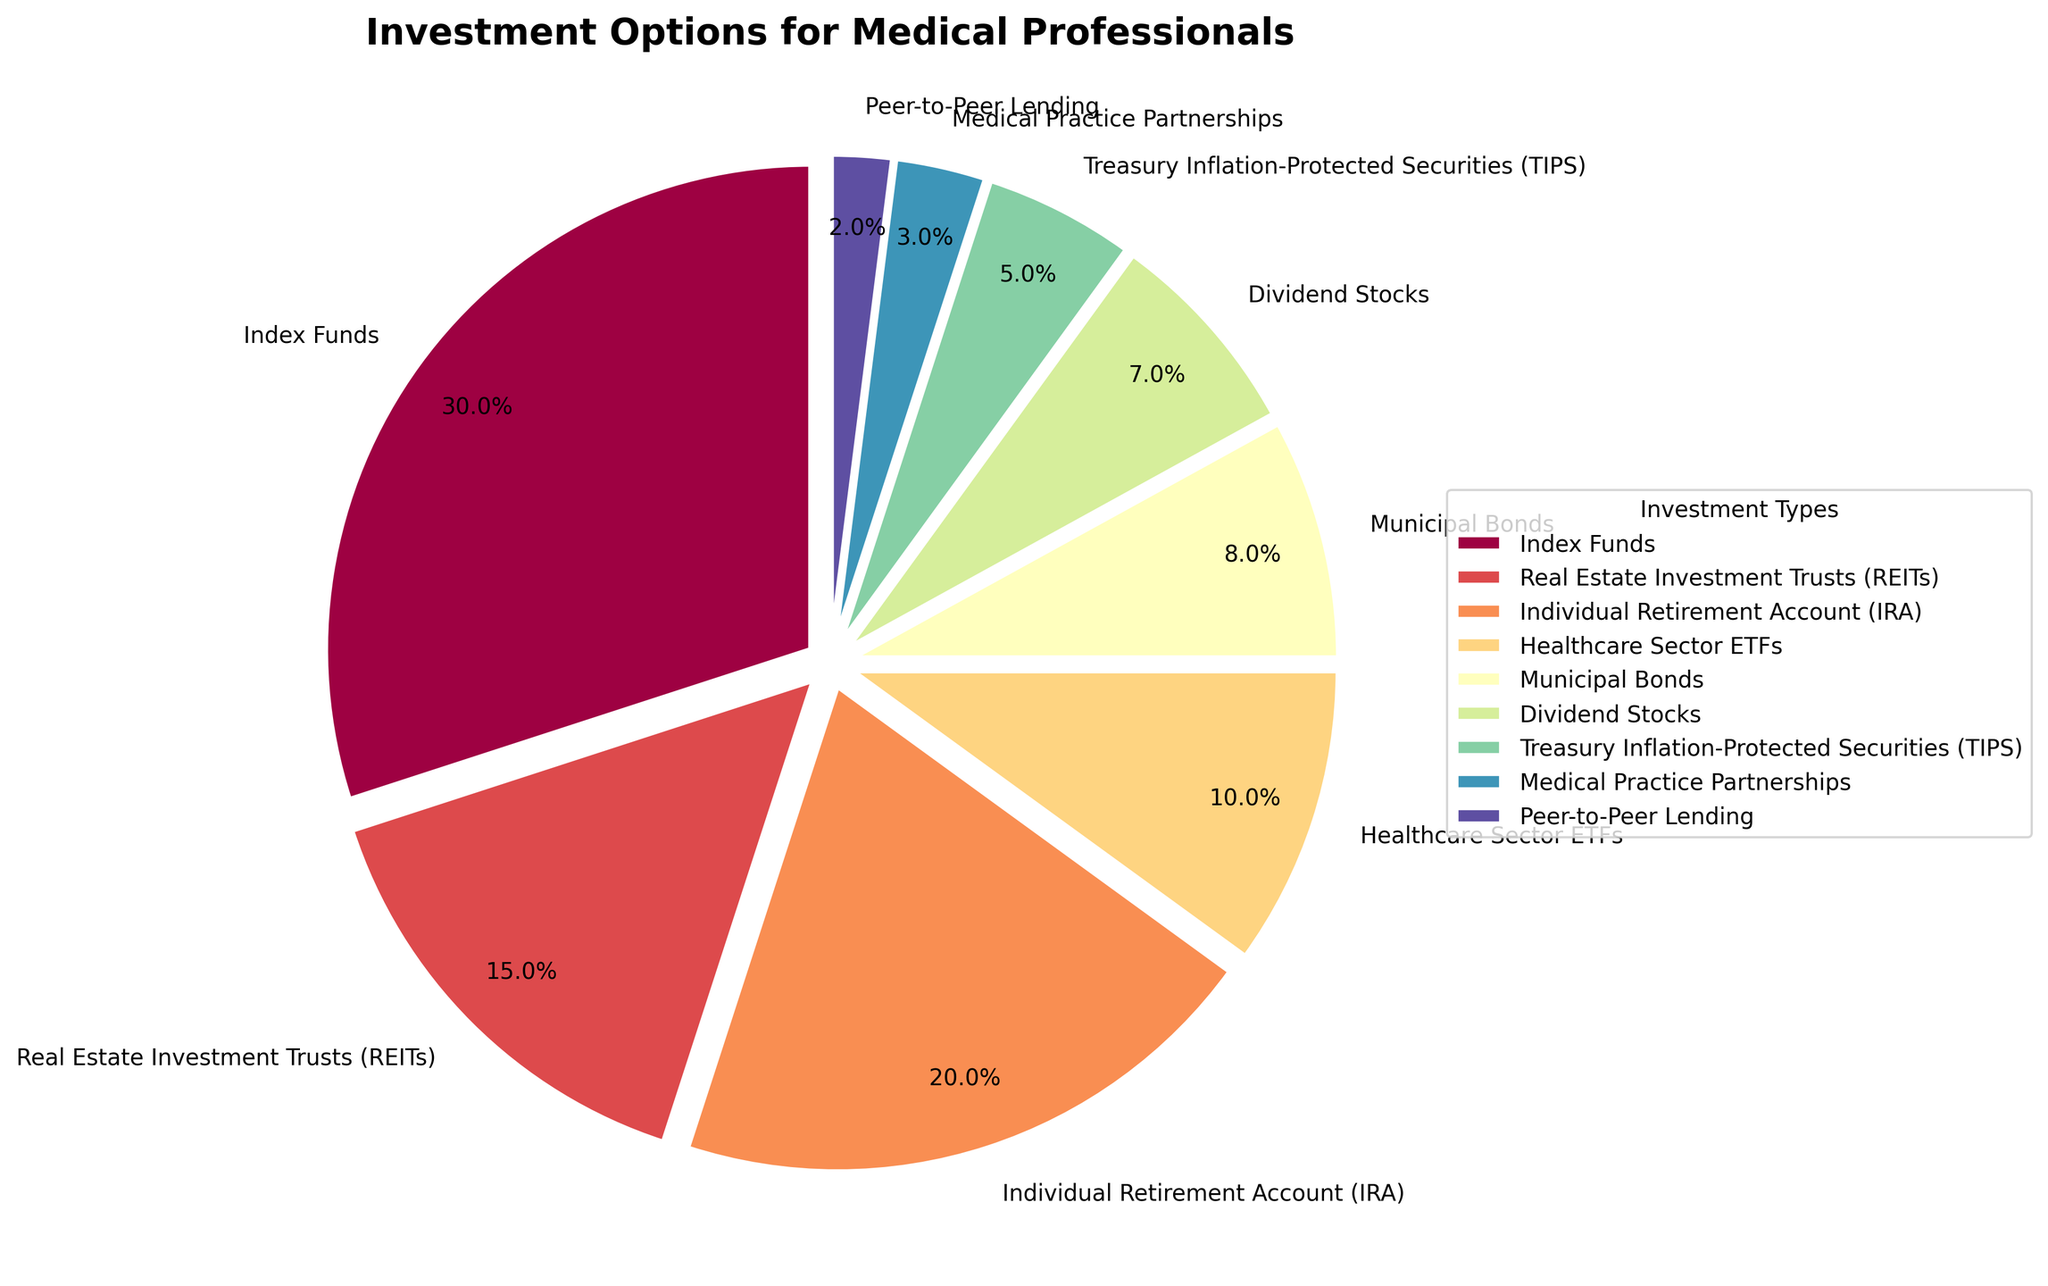Which investment type has the largest percentage? By examining the pie chart, you can see that the "Index Funds" section of the pie chart is the largest.
Answer: Index Funds What is the combined percentage for "Healthcare Sector ETFs" and "Dividend Stocks"? Add the percentages of Healthcare Sector ETFs (10%) and Dividend Stocks (7%): 10 + 7 = 17.
Answer: 17% How does the percentage of "Real Estate Investment Trusts (REITs)" compare to "Individual Retirement Account (IRA)"? By comparing the two segments on the pie chart, it's clear that REITs (15%) is less than IRA (20%).
Answer: Less than Which investment type has the smallest percentage? By finding the smallest segment on the pie chart, you can see that "Peer-to-Peer Lending" has the smallest section at 2%.
Answer: Peer-to-Peer Lending What percentage of the investments are in "Municipal Bonds"? Locate the "Municipal Bonds" segment on the pie chart, which shows 8%.
Answer: 8% Is the combined percentage of "Treasury Inflation-Protected Securities (TIPS)" and "Medical Practice Partnerships" more or less than 10%? Add the percentages of TIPS (5%) and Medical Practice Partnerships (3%): 5 + 3 = 8, which is less than 10%.
Answer: Less than How do "Index Funds" and "Medical Practice Partnerships" compare in terms of percentage? By comparing their segments, Index Funds (30%) is much larger than Medical Practice Partnerships (3%).
Answer: Much larger What is the total percentage of investments not in "Index Funds"? Subtract the percentage of Index Funds (30%) from 100%: 100 - 30 = 70.
Answer: 70% What is the second-largest investment type by percentage? Identify the second-largest section in the pie chart, which is "Individual Retirement Account (IRA)" at 20%.
Answer: Individual Retirement Account (IRA) If you combine the percentages of "Dividend Stocks" and "Medical Practice Partnerships," is it more than "Healthcare Sector ETFs"? Add the percentages of Dividend Stocks (7%) and Medical Practice Partnerships (3%): 7 + 3 = 10%, which is equal to Healthcare Sector ETFs (10%).
Answer: Equal 